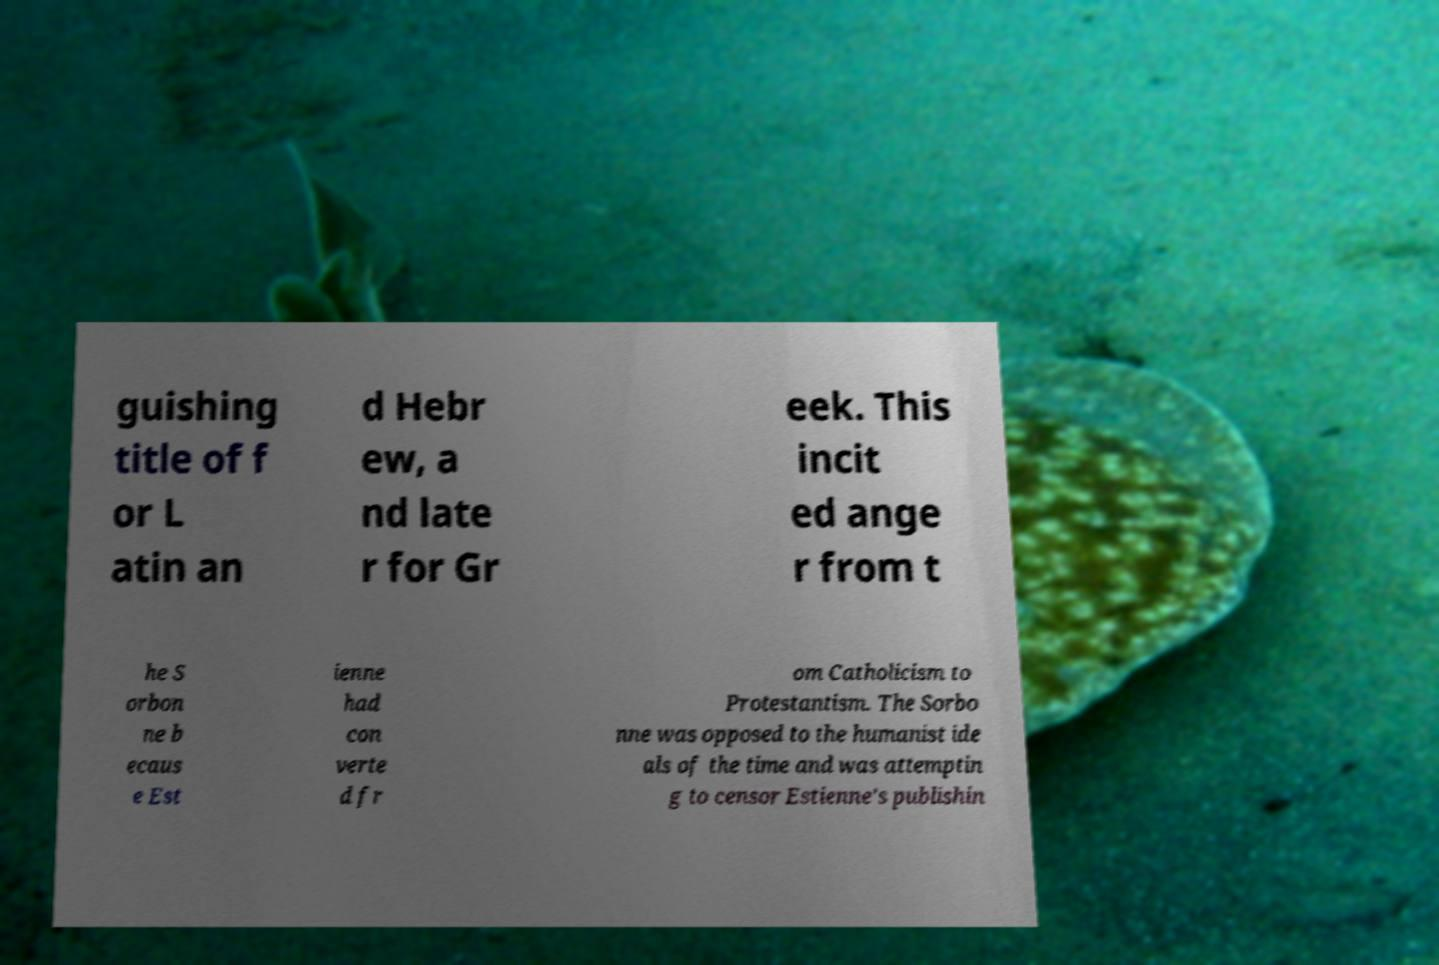Please read and relay the text visible in this image. What does it say? guishing title of f or L atin an d Hebr ew, a nd late r for Gr eek. This incit ed ange r from t he S orbon ne b ecaus e Est ienne had con verte d fr om Catholicism to Protestantism. The Sorbo nne was opposed to the humanist ide als of the time and was attemptin g to censor Estienne's publishin 